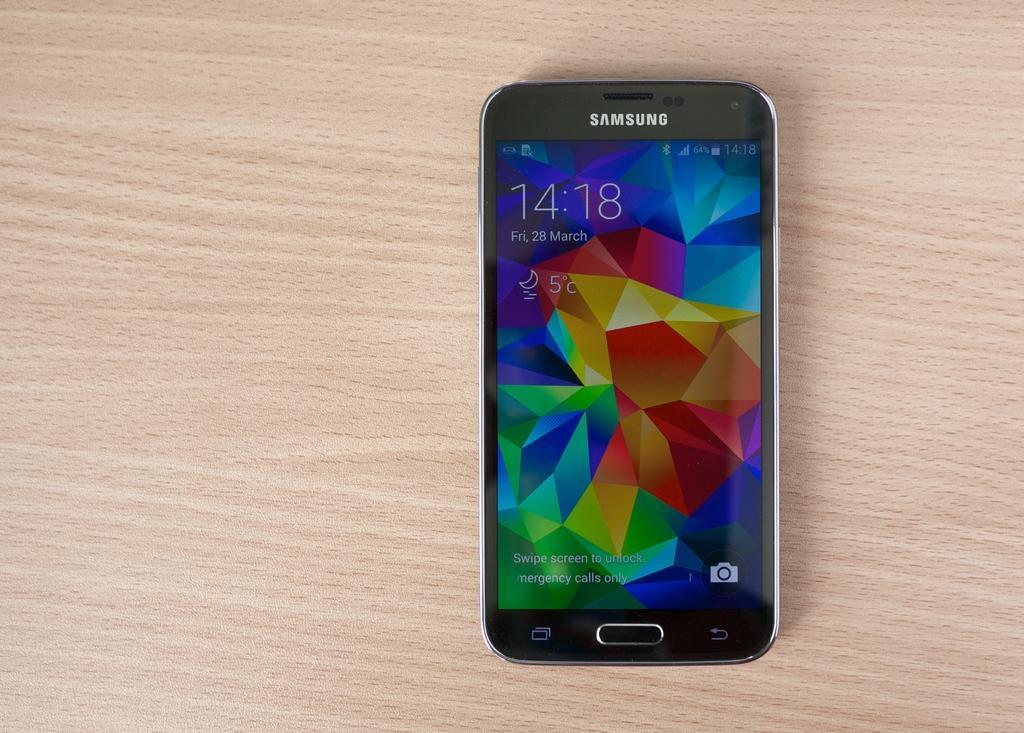How would you summarize this image in a sentence or two? In this image we can see a mobile phone placed on the wooden surface. 